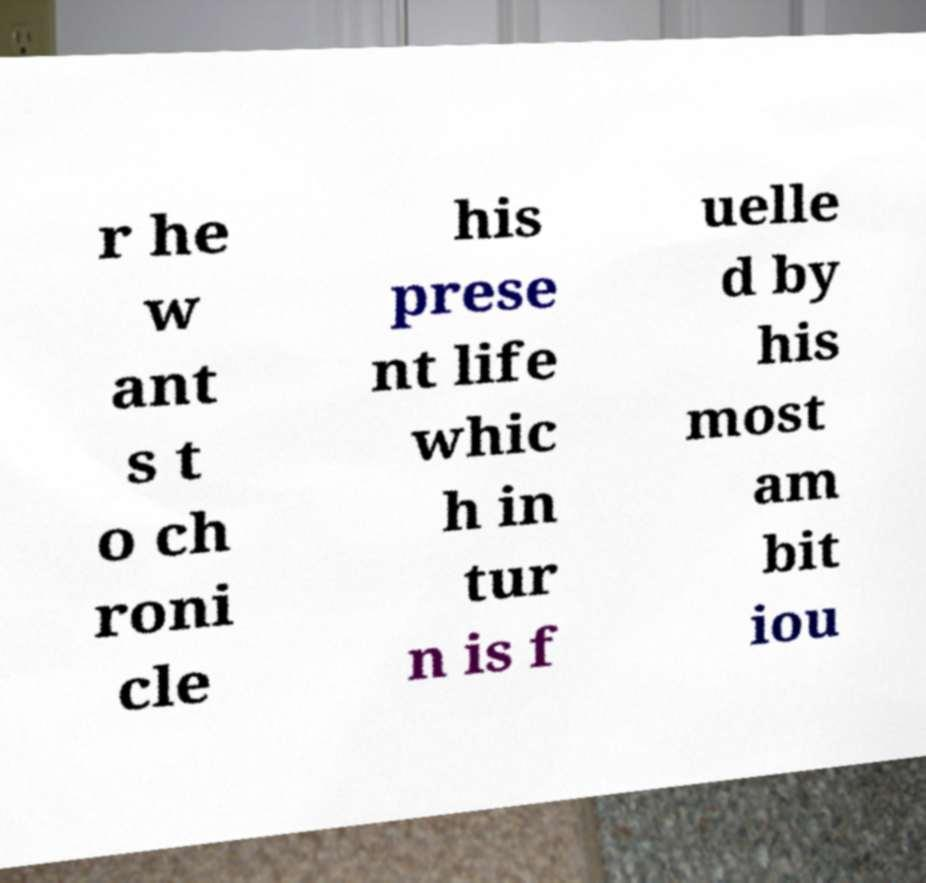Please read and relay the text visible in this image. What does it say? r he w ant s t o ch roni cle his prese nt life whic h in tur n is f uelle d by his most am bit iou 